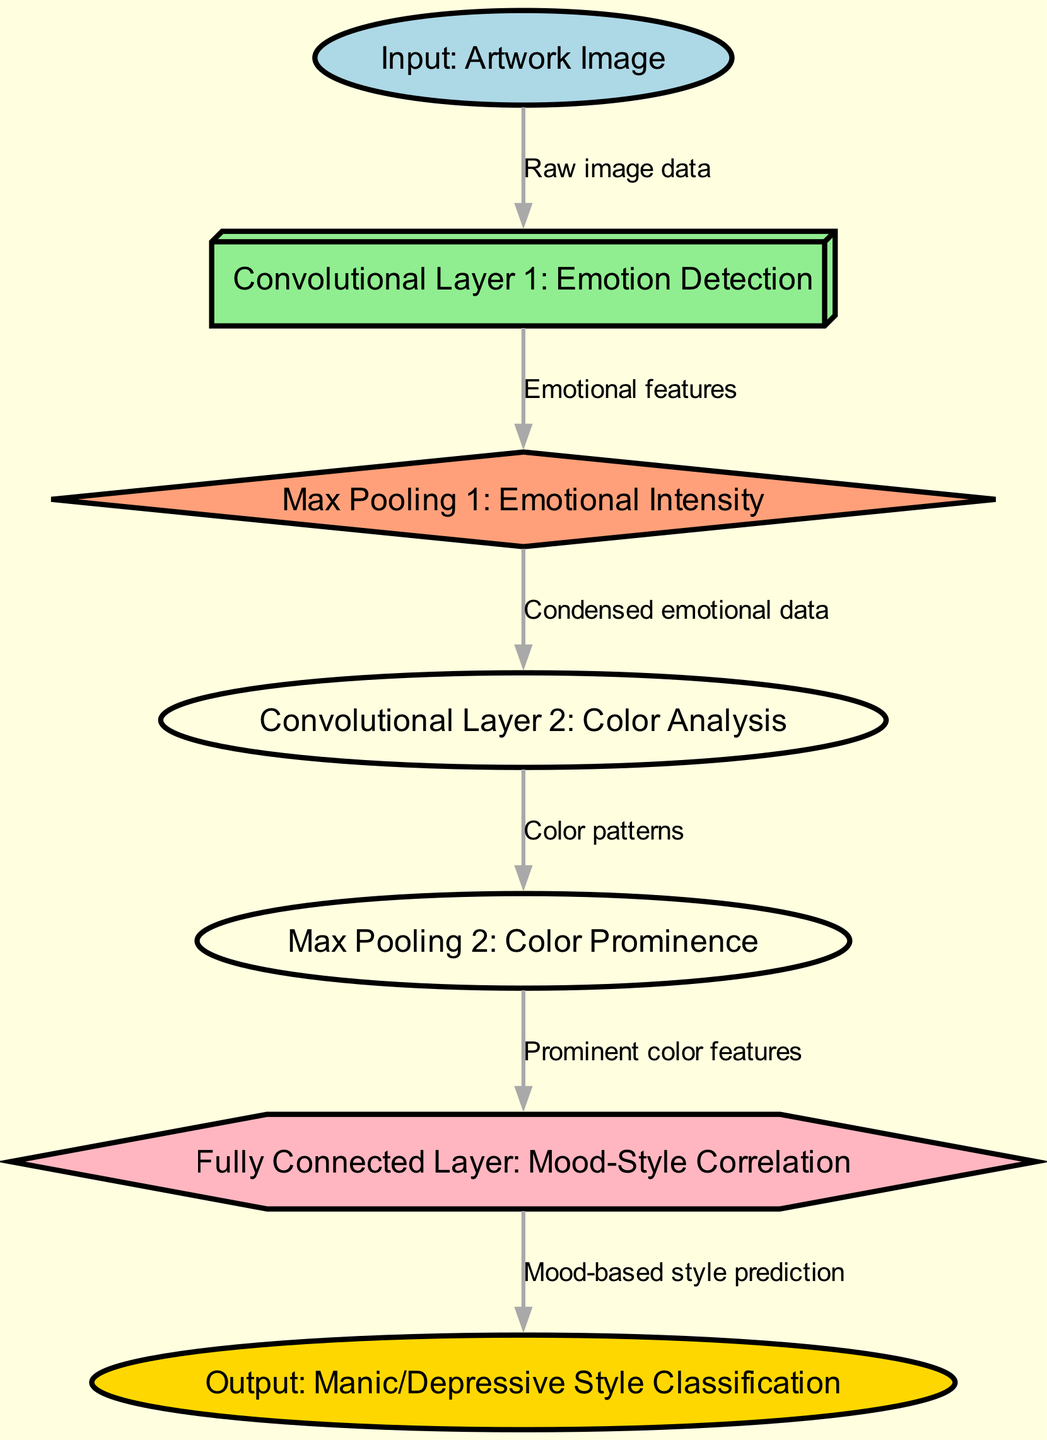What is the first node in the diagram? The first node in the diagram is labeled "Input: Artwork Image." It is the starting point where the raw image data enters the convolutional neural network.
Answer: Input: Artwork Image How many convolutional layers are there? The diagram indicates there are two convolutional layers, as seen under the labels "Convolutional Layer 1: Emotion Detection" and "Convolutional Layer 2: Color Analysis."
Answer: 2 What is the function of Max Pooling 1? Max Pooling 1, labeled as "Max Pooling 1: Emotional Intensity," serves to condense the emotional features extracted from the first convolutional layer, reducing dimensionality while retaining important information.
Answer: Emotional Intensity Which node comes after Max Pooling 2? After Max Pooling 2, the next node is the "Fully Connected Layer: Mood-Style Correlation." This layer processes the prominent color features to determine the mood-style correlation.
Answer: Fully Connected Layer: Mood-Style Correlation What type of output does the diagram provide? The output of the diagram is categorized as "Output: Manic/Depressive Style Classification," indicating the final classification of the artistic style based on mood.
Answer: Manic/Depressive Style Classification What connects Max Pooling 2 to the Fully Connected Layer? Max Pooling 2 is connected to the Fully Connected Layer by the edge labeled "Prominent color features," which carries the relevant information necessary for the fully connected layer to analyze.
Answer: Prominent color features Which layer analyzes color patterns? The layer that analyzes color patterns is "Convolutional Layer 2: Color Analysis." This layer processes the data after the first pooling step and focuses specifically on identifying color patterns in the artwork.
Answer: Convolutional Layer 2: Color Analysis 